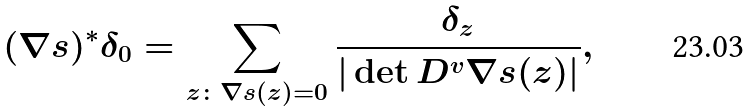<formula> <loc_0><loc_0><loc_500><loc_500>( \nabla s ) ^ { * } \delta _ { 0 } = \sum _ { z \colon \nabla s ( z ) = 0 } \frac { \delta _ { z } } { | \det D ^ { v } \nabla s ( z ) | } ,</formula> 